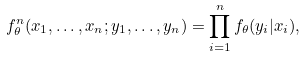<formula> <loc_0><loc_0><loc_500><loc_500>f _ { \theta } ^ { n } ( x _ { 1 } , \dots , x _ { n } ; y _ { 1 } , \dots , y _ { n } ) = \prod _ { i = 1 } ^ { n } f _ { \theta } ( y _ { i } | x _ { i } ) ,</formula> 